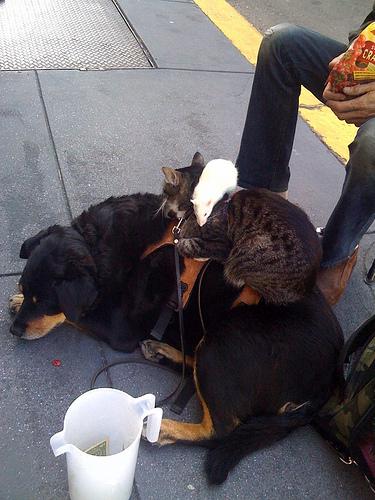What is sitting on the dog's back?
Be succinct. Cat. What is in the pitcher?
Be succinct. Money. What is camo?
Concise answer only. Backpack. 